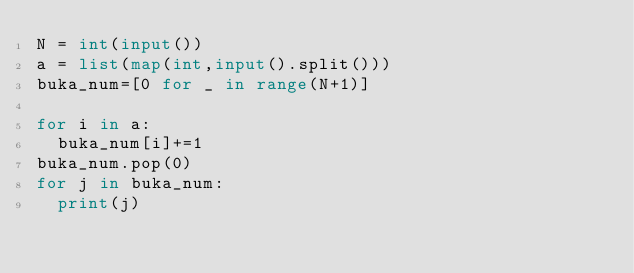Convert code to text. <code><loc_0><loc_0><loc_500><loc_500><_Python_>N = int(input())
a = list(map(int,input().split()))
buka_num=[0 for _ in range(N+1)]

for i in a:
  buka_num[i]+=1
buka_num.pop(0)
for j in buka_num:
  print(j)</code> 